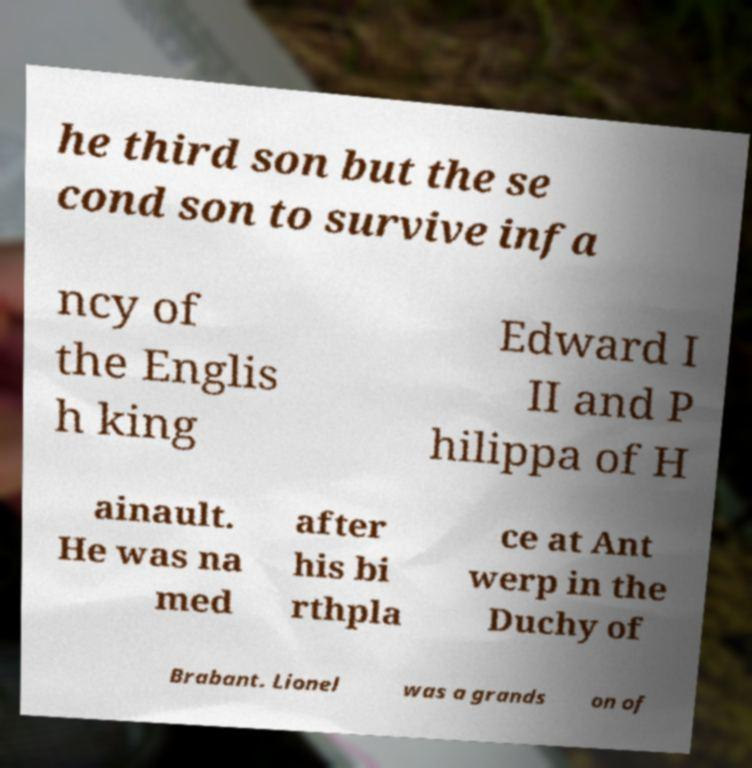There's text embedded in this image that I need extracted. Can you transcribe it verbatim? he third son but the se cond son to survive infa ncy of the Englis h king Edward I II and P hilippa of H ainault. He was na med after his bi rthpla ce at Ant werp in the Duchy of Brabant. Lionel was a grands on of 